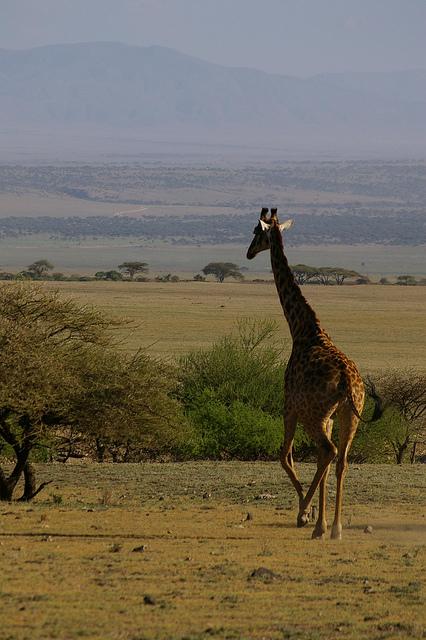Are there trees in this photo?
Quick response, please. Yes. Is the giraffe moving quickly?
Concise answer only. Yes. Is the giraffe facing the tree line?
Short answer required. Yes. Are there mountains in the distance?
Concise answer only. Yes. Is the giraffe alone?
Be succinct. Yes. 